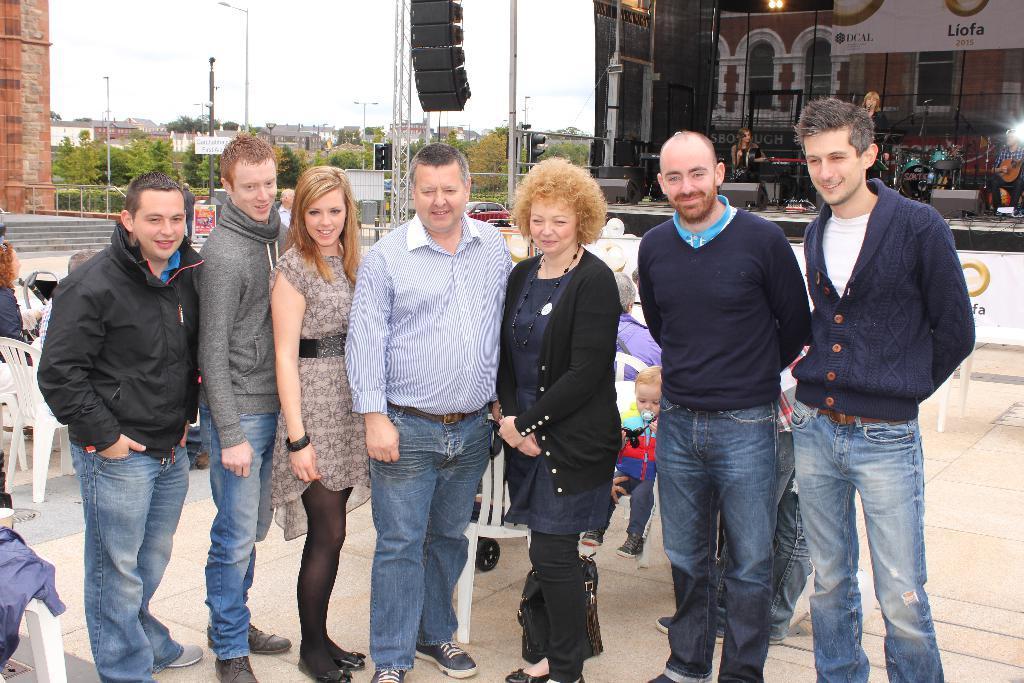Could you give a brief overview of what you see in this image? In this image, there are a few people. Among them, some people are sitting on chairs. We can see the ground. We can also see a stage with some musical instruments. There are a few boards, trees, poles, houses. We can also see the sky and a black colored object at the top. We can also see some stairs and an object on the left. We can also see a vehicle. 